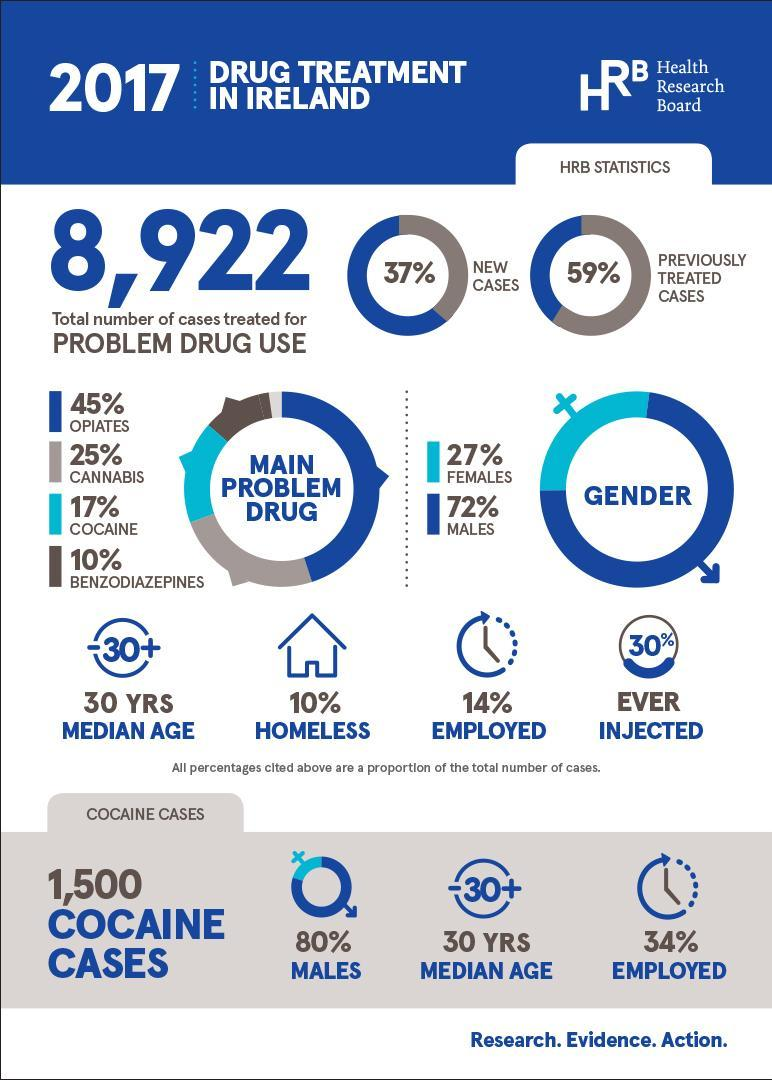What percentage of people undergoing drug treatment are women?
Answer the question with a short phrase. 27% What percent of total number of drug cases are homeless? 10% Majority of people in treatment for drug use are of which gender? Males How many of the total number of cases are employed? 14% What percentage of people in cocaine cases are employed? 34% What is the median age of people using cocaine? 30 What percent of people undergo drug treatment for use of cannabis? 25% Majority of patients undergo treatment because of which problem drug? opiates Which is higher in % - new cases or previously treated cases? previously treated cases What is the number of people treated for problem drug use? 8,922 